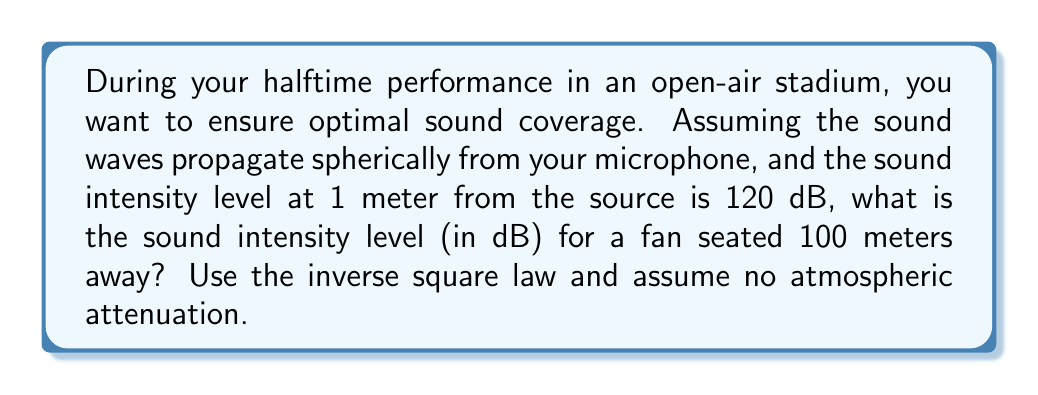Show me your answer to this math problem. Let's approach this step-by-step:

1) The inverse square law for sound intensity states that the intensity is inversely proportional to the square of the distance from the source. Mathematically:

   $$I_2 = I_1 \cdot \left(\frac{r_1}{r_2}\right)^2$$

   Where $I_1$ and $I_2$ are the intensities at distances $r_1$ and $r_2$ respectively.

2) We're given the sound intensity level, not the intensity itself. The relationship between sound intensity level (L) and intensity (I) is:

   $$L = 10 \log_{10}\left(\frac{I}{I_0}\right)$$

   Where $I_0$ is the reference intensity, $10^{-12}$ W/m².

3) At 1 meter, $L_1 = 120$ dB. We need to find $I_1$:

   $$120 = 10 \log_{10}\left(\frac{I_1}{10^{-12}}\right)$$
   $$12 = \log_{10}\left(\frac{I_1}{10^{-12}}\right)$$
   $$I_1 = 10^{-12} \cdot 10^{12} = 1 \text{ W/m}^2$$

4) Now we can use the inverse square law to find $I_2$ at 100 meters:

   $$I_2 = 1 \cdot \left(\frac{1}{100}\right)^2 = 10^{-4} \text{ W/m}^2$$

5) Finally, we convert this intensity back to sound intensity level:

   $$L_2 = 10 \log_{10}\left(\frac{10^{-4}}{10^{-12}}\right) = 10 \log_{10}(10^8) = 80 \text{ dB}$$
Answer: 80 dB 